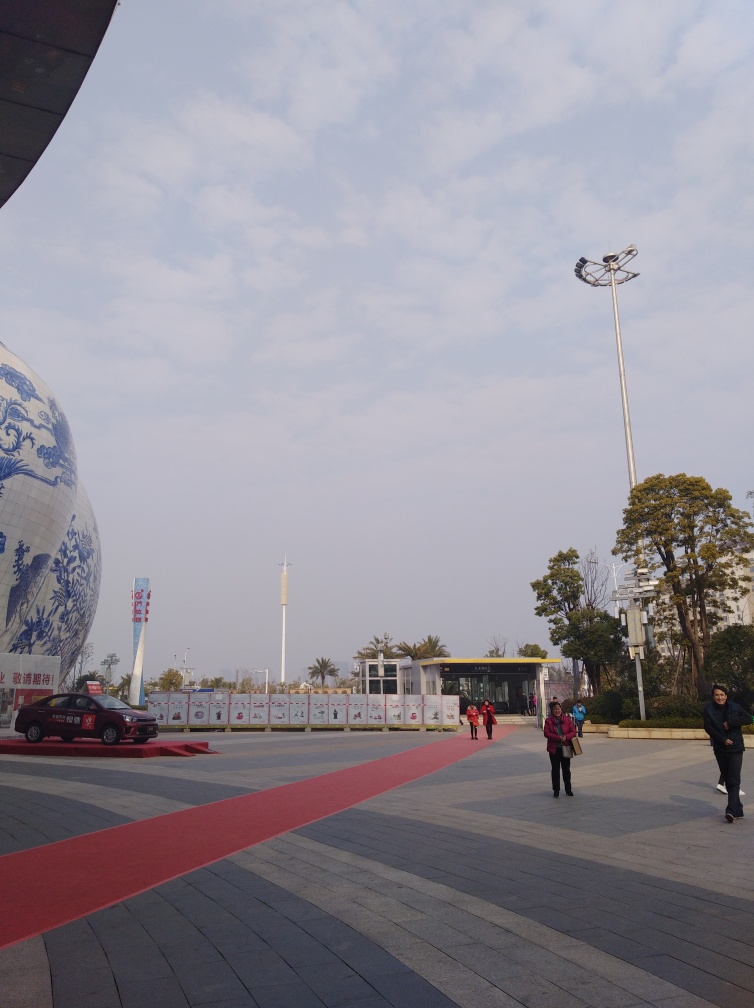What clues can you gather about the location or setting of the image? The architecture and signage suggest an East Asian setting. The banners flanking the red carpet feature characters that may be part of the local language, indicating that it could be a public or cultural venue. The trees do not appear to be fully lush, which might suggest it's either early spring or late autumn. 